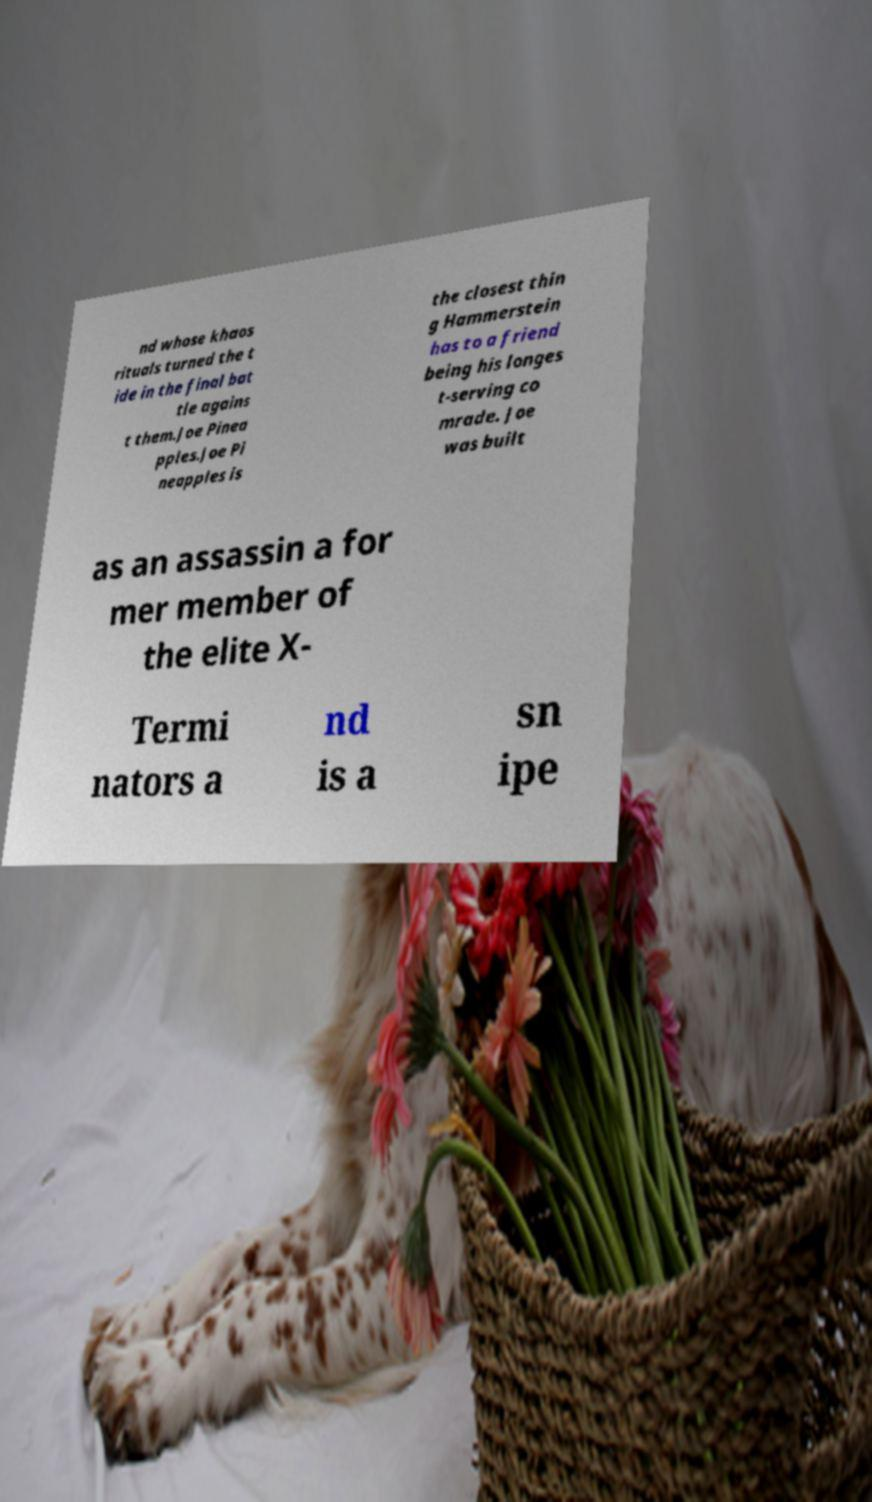There's text embedded in this image that I need extracted. Can you transcribe it verbatim? nd whose khaos rituals turned the t ide in the final bat tle agains t them.Joe Pinea pples.Joe Pi neapples is the closest thin g Hammerstein has to a friend being his longes t-serving co mrade. Joe was built as an assassin a for mer member of the elite X- Termi nators a nd is a sn ipe 